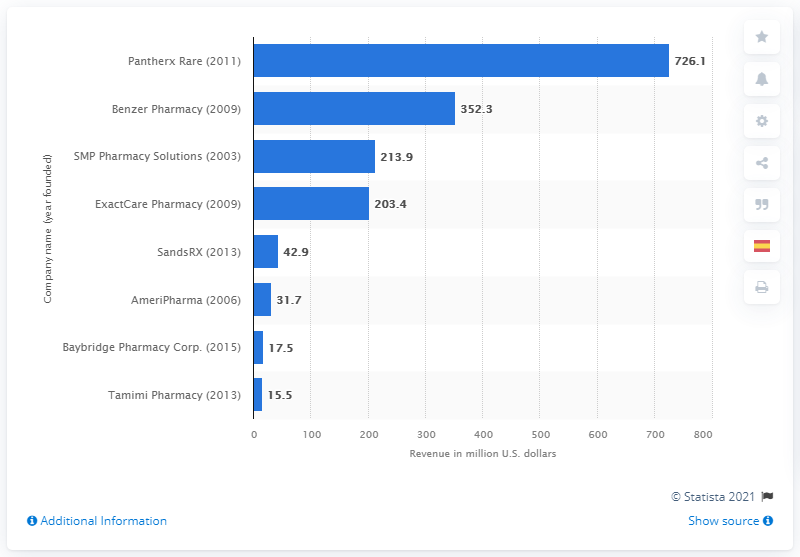Highlight a few significant elements in this photo. Benzer Pharmacy generated approximately $352.3 million in revenue in 2018. 